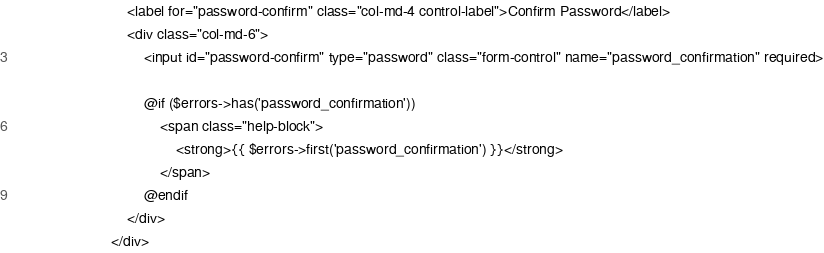Convert code to text. <code><loc_0><loc_0><loc_500><loc_500><_PHP_>                            <label for="password-confirm" class="col-md-4 control-label">Confirm Password</label>
                            <div class="col-md-6">
                                <input id="password-confirm" type="password" class="form-control" name="password_confirmation" required>

                                @if ($errors->has('password_confirmation'))
                                    <span class="help-block">
                                        <strong>{{ $errors->first('password_confirmation') }}</strong>
                                    </span>
                                @endif
                            </div>
                        </div>
</code> 